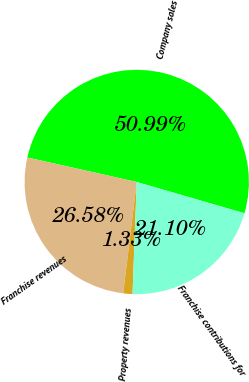Convert chart. <chart><loc_0><loc_0><loc_500><loc_500><pie_chart><fcel>Company sales<fcel>Franchise revenues<fcel>Property revenues<fcel>Franchise contributions for<nl><fcel>50.99%<fcel>26.58%<fcel>1.33%<fcel>21.1%<nl></chart> 